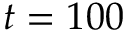Convert formula to latex. <formula><loc_0><loc_0><loc_500><loc_500>t = 1 0 0</formula> 